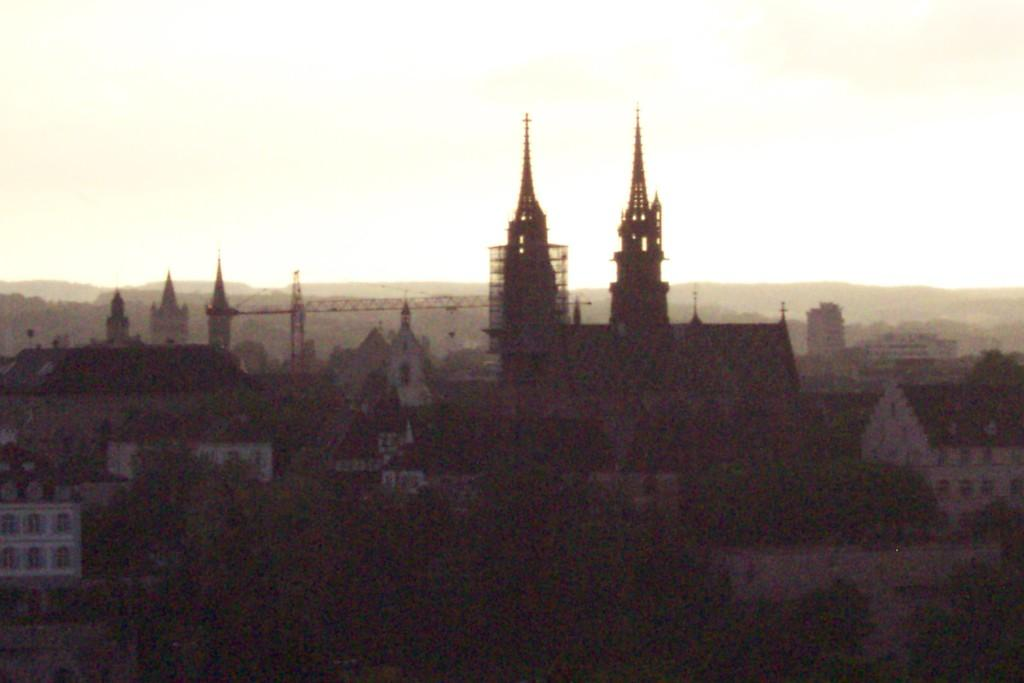What is the overall lighting condition in the image? The image is dark. What type of structures can be seen in the image? There are buildings in the image. What other natural elements are present in the image? There are trees in the image. What type of machinery is visible in the image? There are cranes in the image. What can be seen in the background of the image? The sky is visible in the background of the image. How many family members can be seen on the journey in the image? There is no family or journey depicted in the image; it features buildings, trees, cranes, and a dark sky. What type of bead is used to decorate the trees in the image? There are no beads present in the image; it features buildings, trees, cranes, and a dark sky. 